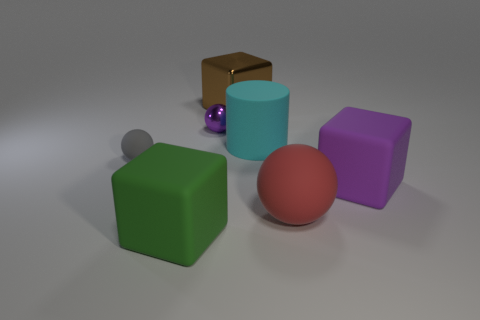Add 2 tiny green rubber cylinders. How many objects exist? 9 Subtract all blocks. How many objects are left? 4 Subtract all small purple metallic things. Subtract all large shiny objects. How many objects are left? 5 Add 2 purple shiny balls. How many purple shiny balls are left? 3 Add 7 large gray cubes. How many large gray cubes exist? 7 Subtract 1 green cubes. How many objects are left? 6 